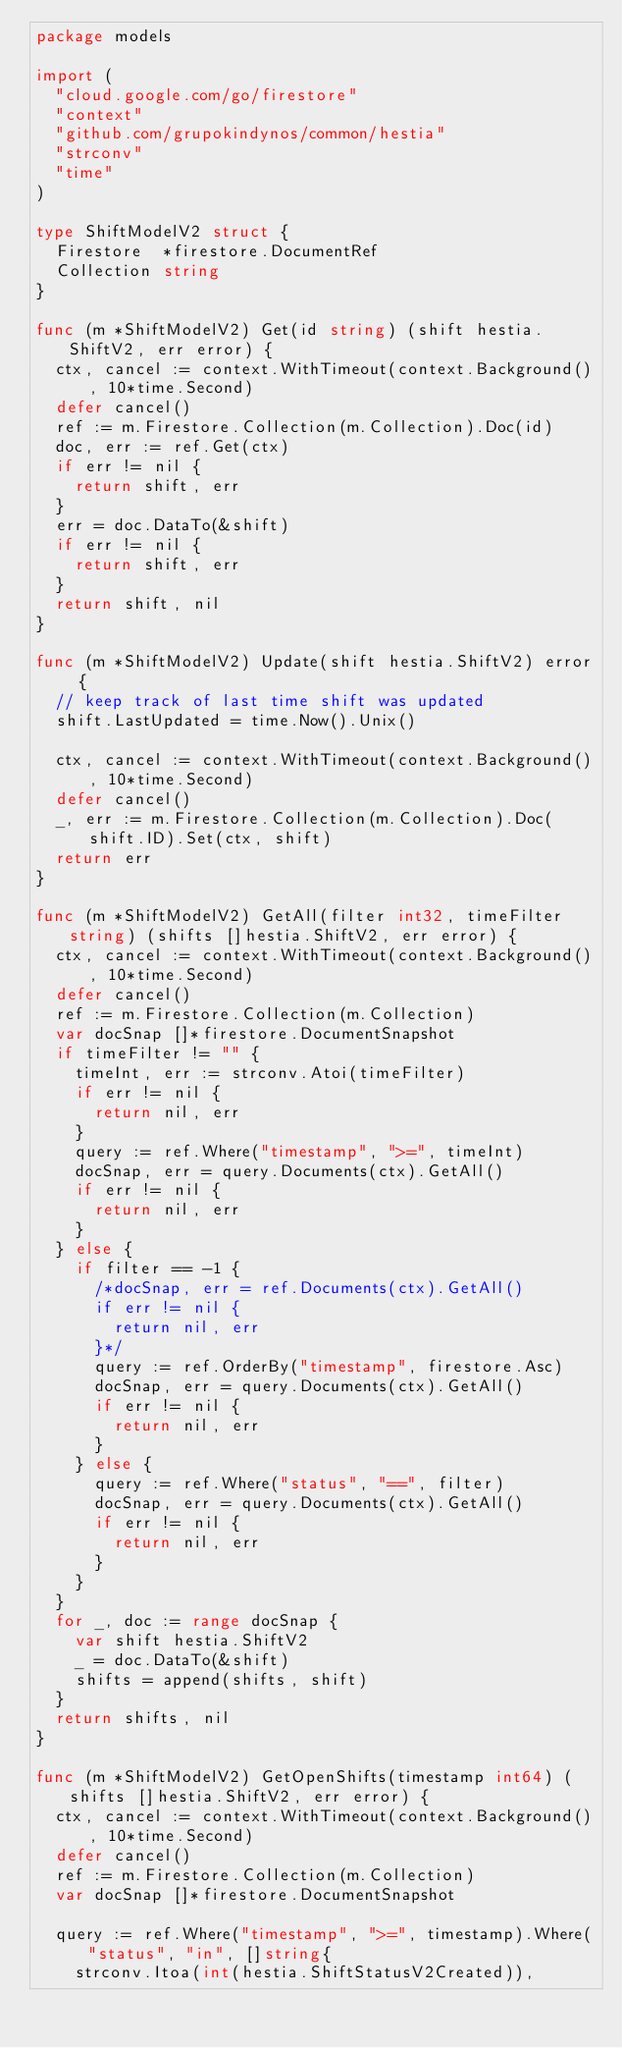Convert code to text. <code><loc_0><loc_0><loc_500><loc_500><_Go_>package models

import (
	"cloud.google.com/go/firestore"
	"context"
	"github.com/grupokindynos/common/hestia"
	"strconv"
	"time"
)

type ShiftModelV2 struct {
	Firestore  *firestore.DocumentRef
	Collection string
}

func (m *ShiftModelV2) Get(id string) (shift hestia.ShiftV2, err error) {
	ctx, cancel := context.WithTimeout(context.Background(), 10*time.Second)
	defer cancel()
	ref := m.Firestore.Collection(m.Collection).Doc(id)
	doc, err := ref.Get(ctx)
	if err != nil {
		return shift, err
	}
	err = doc.DataTo(&shift)
	if err != nil {
		return shift, err
	}
	return shift, nil
}

func (m *ShiftModelV2) Update(shift hestia.ShiftV2) error {
	// keep track of last time shift was updated
	shift.LastUpdated = time.Now().Unix()

	ctx, cancel := context.WithTimeout(context.Background(), 10*time.Second)
	defer cancel()
	_, err := m.Firestore.Collection(m.Collection).Doc(shift.ID).Set(ctx, shift)
	return err
}

func (m *ShiftModelV2) GetAll(filter int32, timeFilter string) (shifts []hestia.ShiftV2, err error) {
	ctx, cancel := context.WithTimeout(context.Background(), 10*time.Second)
	defer cancel()
	ref := m.Firestore.Collection(m.Collection)
	var docSnap []*firestore.DocumentSnapshot
	if timeFilter != "" {
		timeInt, err := strconv.Atoi(timeFilter)
		if err != nil {
			return nil, err
		}
		query := ref.Where("timestamp", ">=", timeInt)
		docSnap, err = query.Documents(ctx).GetAll()
		if err != nil {
			return nil, err
		}
	} else {
		if filter == -1 {
			/*docSnap, err = ref.Documents(ctx).GetAll()
			if err != nil {
				return nil, err
			}*/
			query := ref.OrderBy("timestamp", firestore.Asc)
			docSnap, err = query.Documents(ctx).GetAll()
			if err != nil {
				return nil, err
			}
		} else {
			query := ref.Where("status", "==", filter)
			docSnap, err = query.Documents(ctx).GetAll()
			if err != nil {
				return nil, err
			}
		}
	}
	for _, doc := range docSnap {
		var shift hestia.ShiftV2
		_ = doc.DataTo(&shift)
		shifts = append(shifts, shift)
	}
	return shifts, nil
}

func (m *ShiftModelV2) GetOpenShifts(timestamp int64) (shifts []hestia.ShiftV2, err error) {
	ctx, cancel := context.WithTimeout(context.Background(), 10*time.Second)
	defer cancel()
	ref := m.Firestore.Collection(m.Collection)
	var docSnap []*firestore.DocumentSnapshot

	query := ref.Where("timestamp", ">=", timestamp).Where("status", "in", []string{
		strconv.Itoa(int(hestia.ShiftStatusV2Created)),</code> 